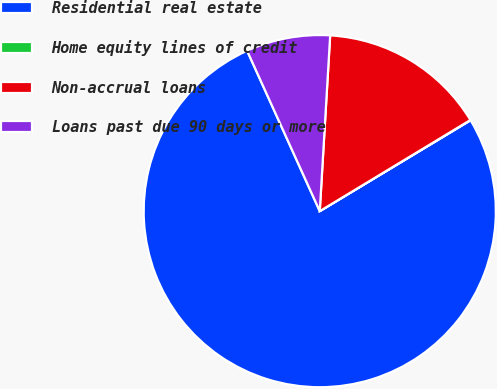Convert chart to OTSL. <chart><loc_0><loc_0><loc_500><loc_500><pie_chart><fcel>Residential real estate<fcel>Home equity lines of credit<fcel>Non-accrual loans<fcel>Loans past due 90 days or more<nl><fcel>76.87%<fcel>0.03%<fcel>15.4%<fcel>7.71%<nl></chart> 